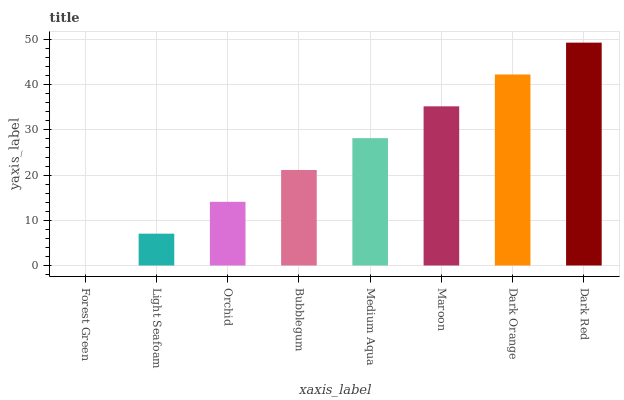Is Forest Green the minimum?
Answer yes or no. Yes. Is Dark Red the maximum?
Answer yes or no. Yes. Is Light Seafoam the minimum?
Answer yes or no. No. Is Light Seafoam the maximum?
Answer yes or no. No. Is Light Seafoam greater than Forest Green?
Answer yes or no. Yes. Is Forest Green less than Light Seafoam?
Answer yes or no. Yes. Is Forest Green greater than Light Seafoam?
Answer yes or no. No. Is Light Seafoam less than Forest Green?
Answer yes or no. No. Is Medium Aqua the high median?
Answer yes or no. Yes. Is Bubblegum the low median?
Answer yes or no. Yes. Is Dark Orange the high median?
Answer yes or no. No. Is Dark Red the low median?
Answer yes or no. No. 